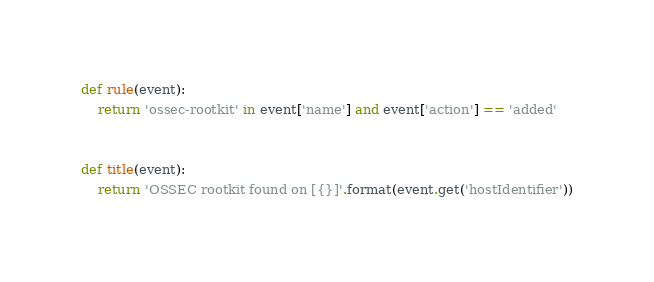Convert code to text. <code><loc_0><loc_0><loc_500><loc_500><_Python_>def rule(event):
    return 'ossec-rootkit' in event['name'] and event['action'] == 'added'


def title(event):
    return 'OSSEC rootkit found on [{}]'.format(event.get('hostIdentifier'))
</code> 